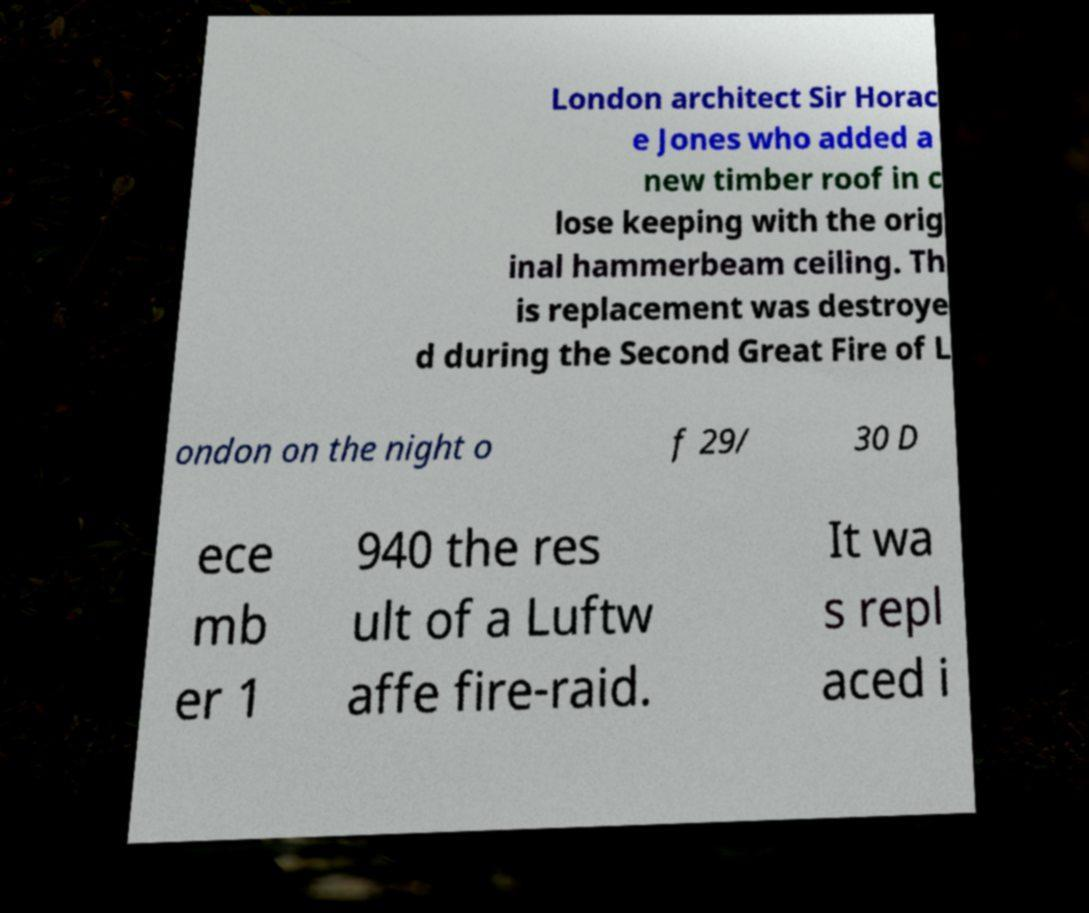There's text embedded in this image that I need extracted. Can you transcribe it verbatim? London architect Sir Horac e Jones who added a new timber roof in c lose keeping with the orig inal hammerbeam ceiling. Th is replacement was destroye d during the Second Great Fire of L ondon on the night o f 29/ 30 D ece mb er 1 940 the res ult of a Luftw affe fire-raid. It wa s repl aced i 